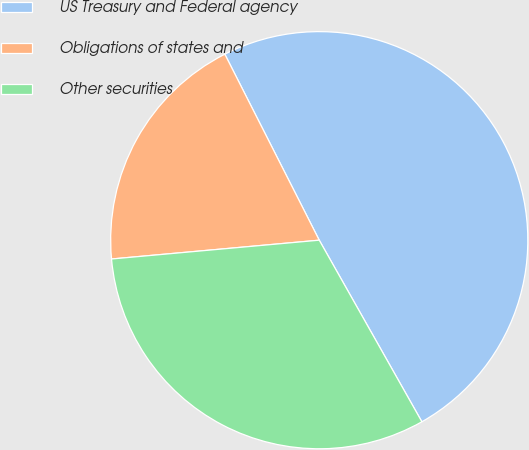<chart> <loc_0><loc_0><loc_500><loc_500><pie_chart><fcel>US Treasury and Federal agency<fcel>Obligations of states and<fcel>Other securities<nl><fcel>49.29%<fcel>18.96%<fcel>31.75%<nl></chart> 